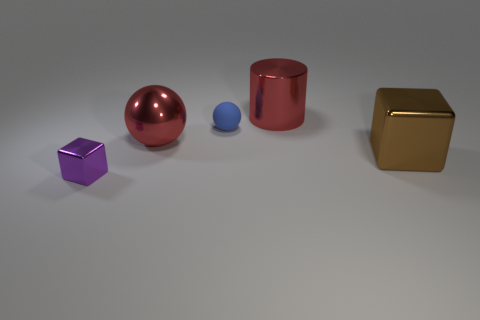Subtract all blocks. How many objects are left? 3 Subtract 2 spheres. How many spheres are left? 0 Subtract all gray cylinders. Subtract all purple blocks. How many cylinders are left? 1 Subtract all cyan spheres. How many purple cubes are left? 1 Subtract all matte things. Subtract all red cylinders. How many objects are left? 3 Add 4 small cubes. How many small cubes are left? 5 Add 5 purple cylinders. How many purple cylinders exist? 5 Add 3 tiny balls. How many objects exist? 8 Subtract all blue balls. How many balls are left? 1 Subtract 0 yellow cubes. How many objects are left? 5 